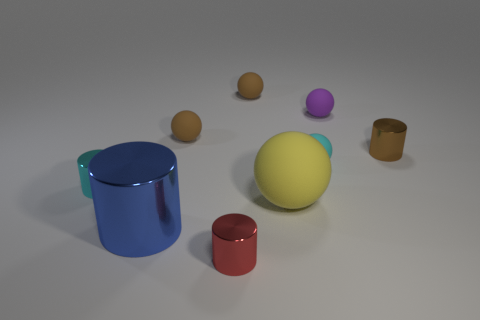There is a blue cylinder that is the same material as the small cyan cylinder; what size is it?
Your response must be concise. Large. Are there any small brown things made of the same material as the purple ball?
Keep it short and to the point. Yes. What is the color of the small thing that is both in front of the brown cylinder and on the right side of the red cylinder?
Provide a succinct answer. Cyan. What is the shape of the thing behind the small purple matte thing?
Offer a terse response. Sphere. Are the large ball and the large cylinder made of the same material?
Your answer should be compact. No. Do the large matte ball and the large shiny object have the same color?
Make the answer very short. No. Are there more blue shiny things on the right side of the red thing than big green cylinders?
Offer a terse response. No. How many small brown rubber spheres are behind the ball that is on the left side of the tiny red cylinder?
Provide a short and direct response. 1. Do the small ball in front of the small brown metal thing and the small thing left of the big blue shiny cylinder have the same material?
Your response must be concise. No. What number of blue shiny objects are the same shape as the purple thing?
Ensure brevity in your answer.  0. 